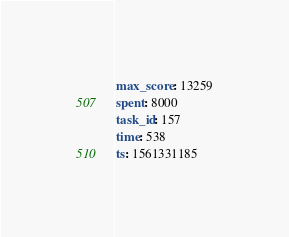<code> <loc_0><loc_0><loc_500><loc_500><_YAML_>max_score: 13259
spent: 8000
task_id: 157
time: 538
ts: 1561331185
</code> 